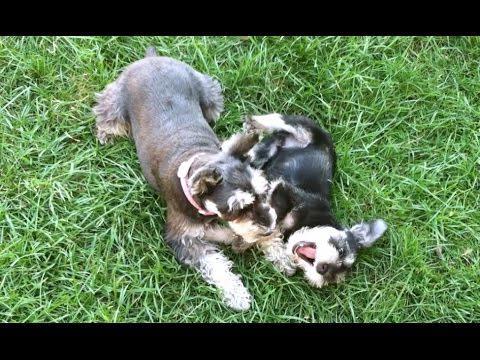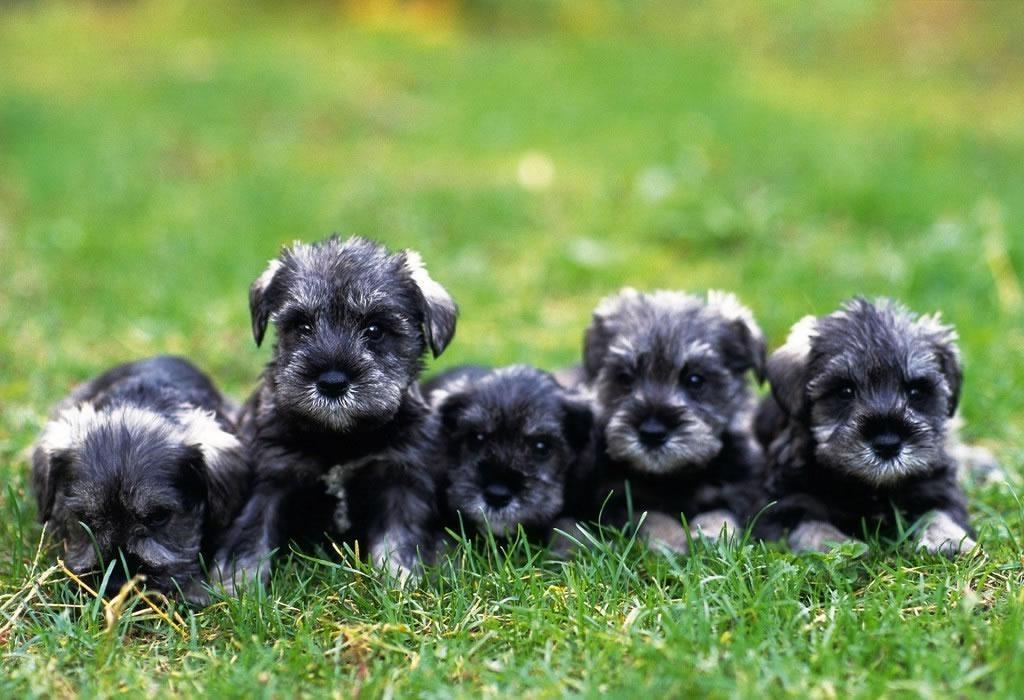The first image is the image on the left, the second image is the image on the right. Given the left and right images, does the statement "An image shows one schnauzer puppy standing in the grass near a toy." hold true? Answer yes or no. No. The first image is the image on the left, the second image is the image on the right. Assess this claim about the two images: "A single dog stands in the grass in the image on the right.". Correct or not? Answer yes or no. No. 